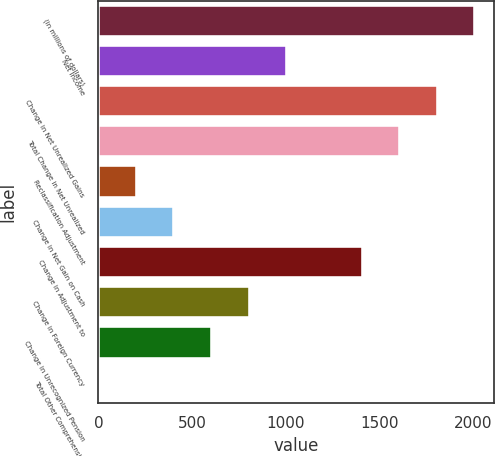<chart> <loc_0><loc_0><loc_500><loc_500><bar_chart><fcel>(in millions of dollars)<fcel>Net Income<fcel>Change in Net Unrealized Gains<fcel>Total Change in Net Unrealized<fcel>Reclassification Adjustment<fcel>Change in Net Gain on Cash<fcel>Change in Adjustment to<fcel>Change in Foreign Currency<fcel>Change in Unrecognized Pension<fcel>Total Other Comprehensive<nl><fcel>2010<fcel>1006.95<fcel>1809.39<fcel>1608.78<fcel>204.51<fcel>405.12<fcel>1408.17<fcel>806.34<fcel>605.73<fcel>3.9<nl></chart> 